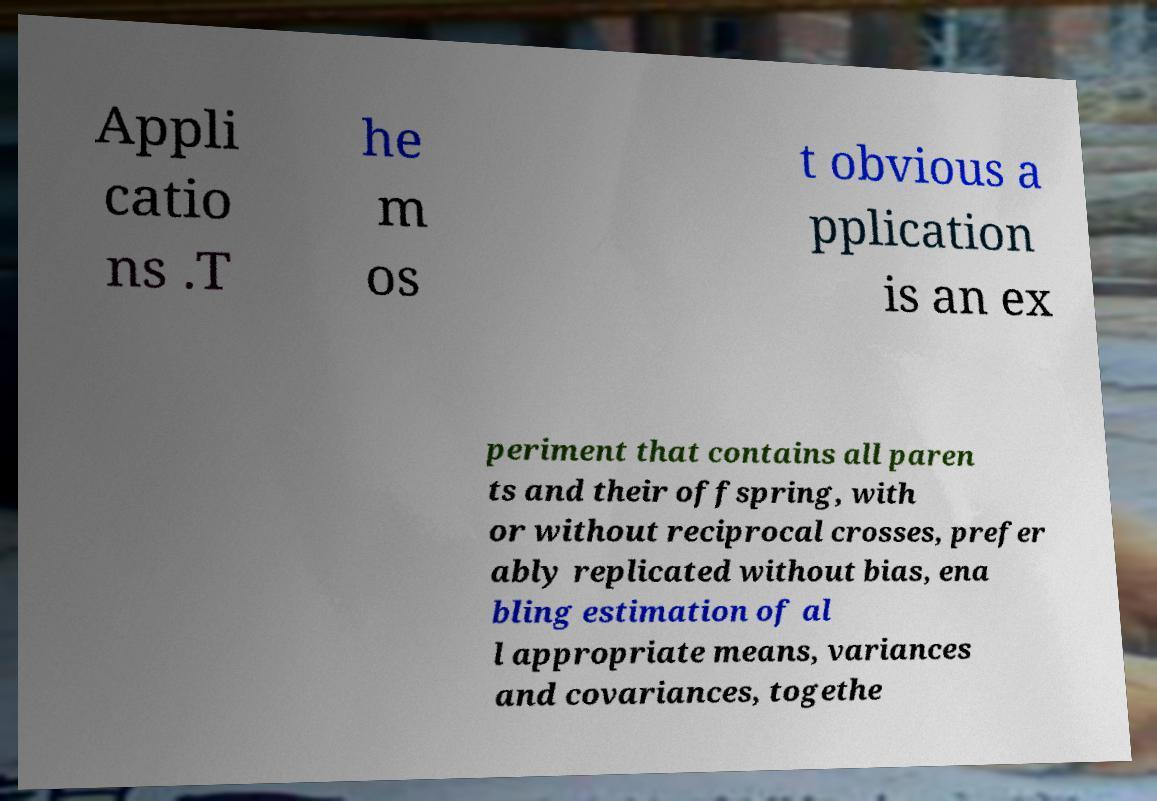Can you read and provide the text displayed in the image?This photo seems to have some interesting text. Can you extract and type it out for me? Appli catio ns .T he m os t obvious a pplication is an ex periment that contains all paren ts and their offspring, with or without reciprocal crosses, prefer ably replicated without bias, ena bling estimation of al l appropriate means, variances and covariances, togethe 